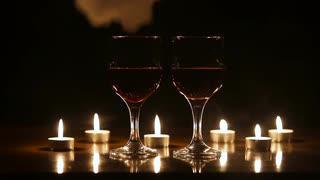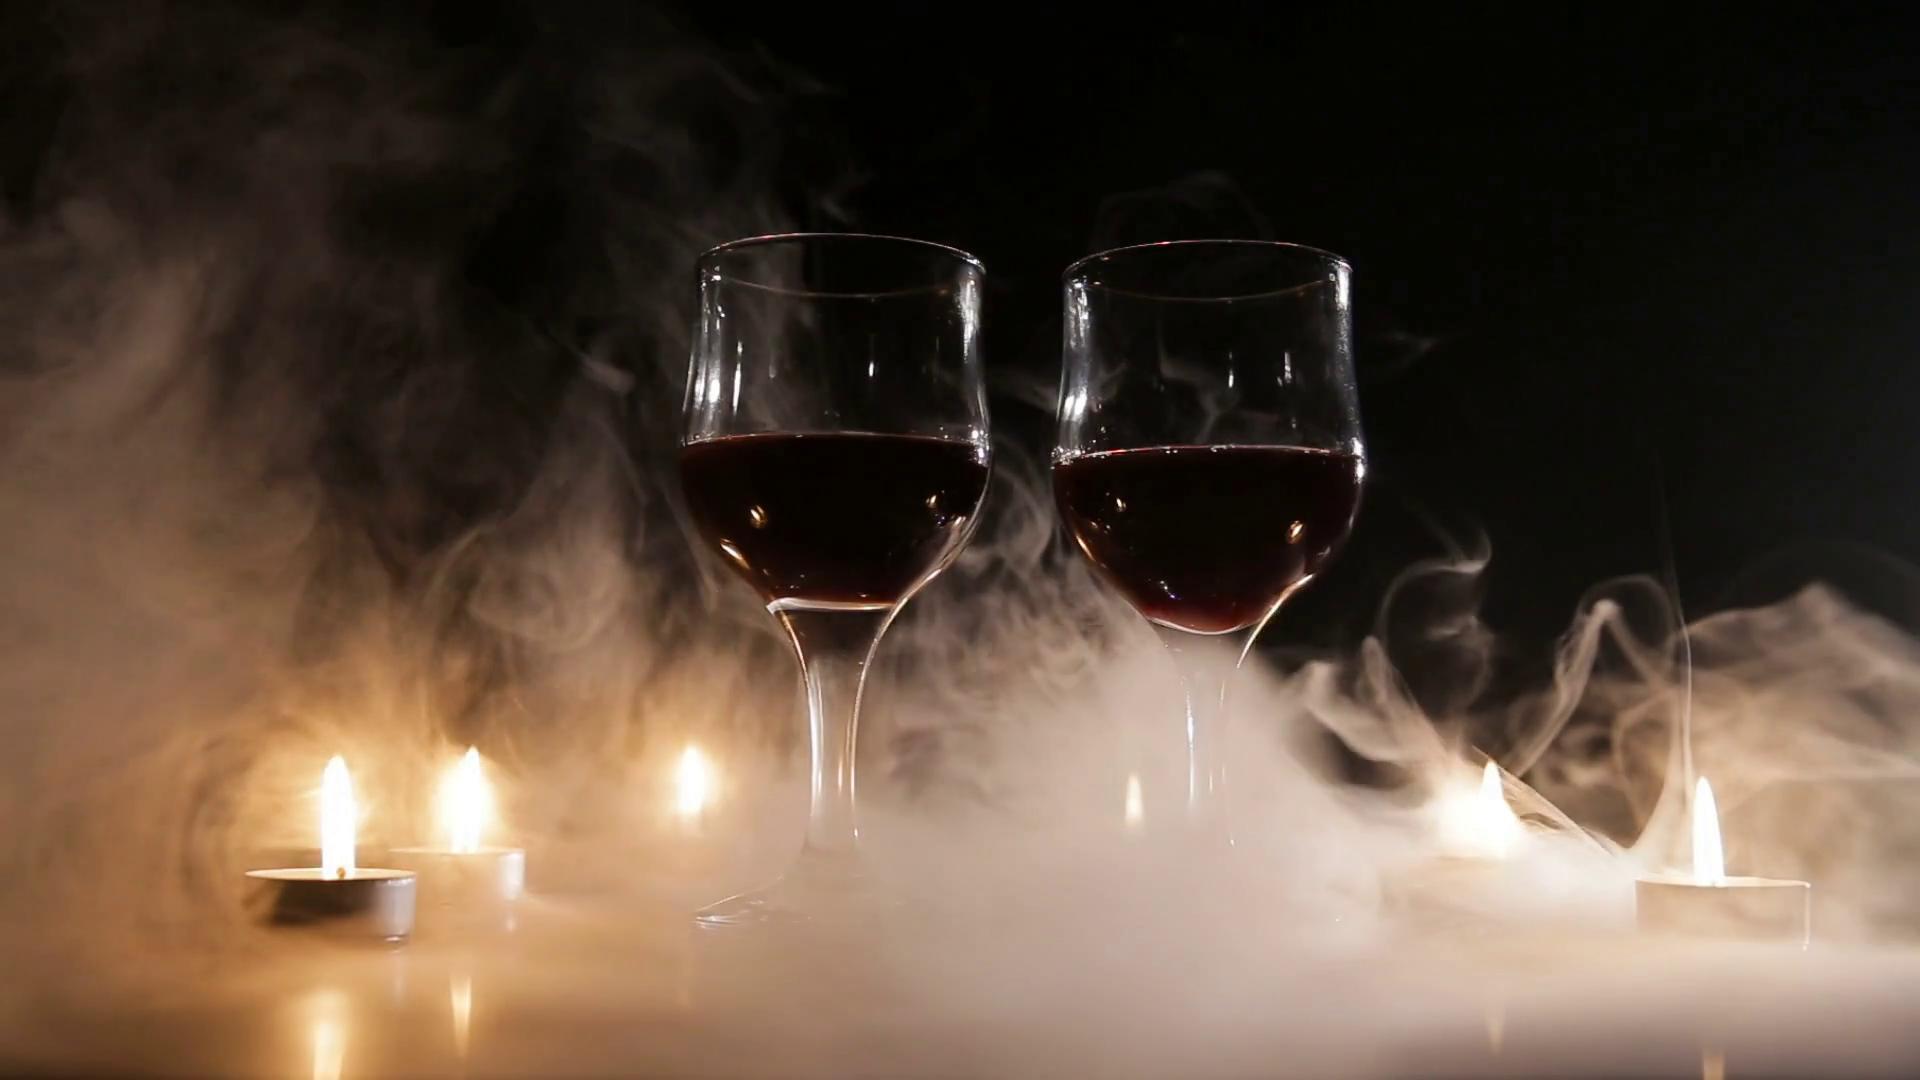The first image is the image on the left, the second image is the image on the right. For the images displayed, is the sentence "An image shows wisps of white smoke around two glasses of dark red wine, standing near candles." factually correct? Answer yes or no. Yes. 